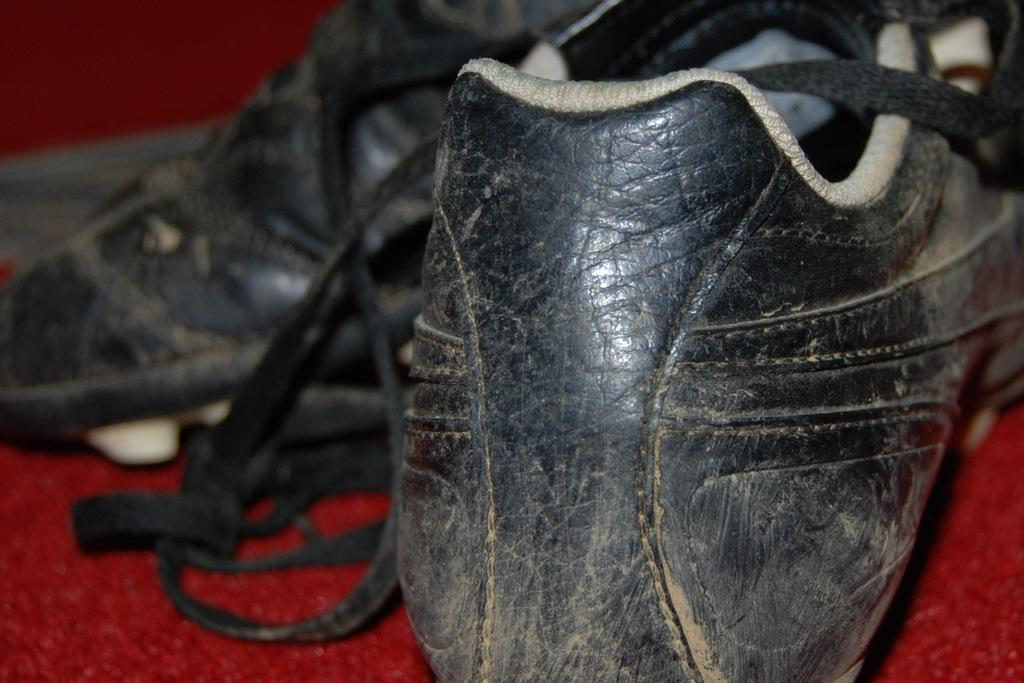What type of object is present in the image? There is footwear in the image. What is the footwear placed on? The footwear is on a red surface. What color is the background of the image? The background of the image is red. What type of actor can be seen performing in the image? There is no actor present in the image; it features footwear on a red surface with a red background. 